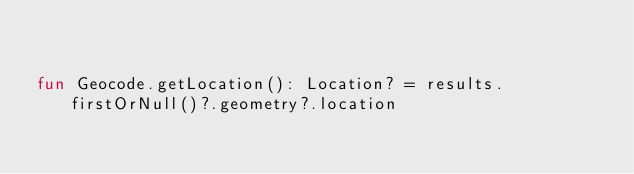<code> <loc_0><loc_0><loc_500><loc_500><_Kotlin_>

fun Geocode.getLocation(): Location? = results.firstOrNull()?.geometry?.location</code> 